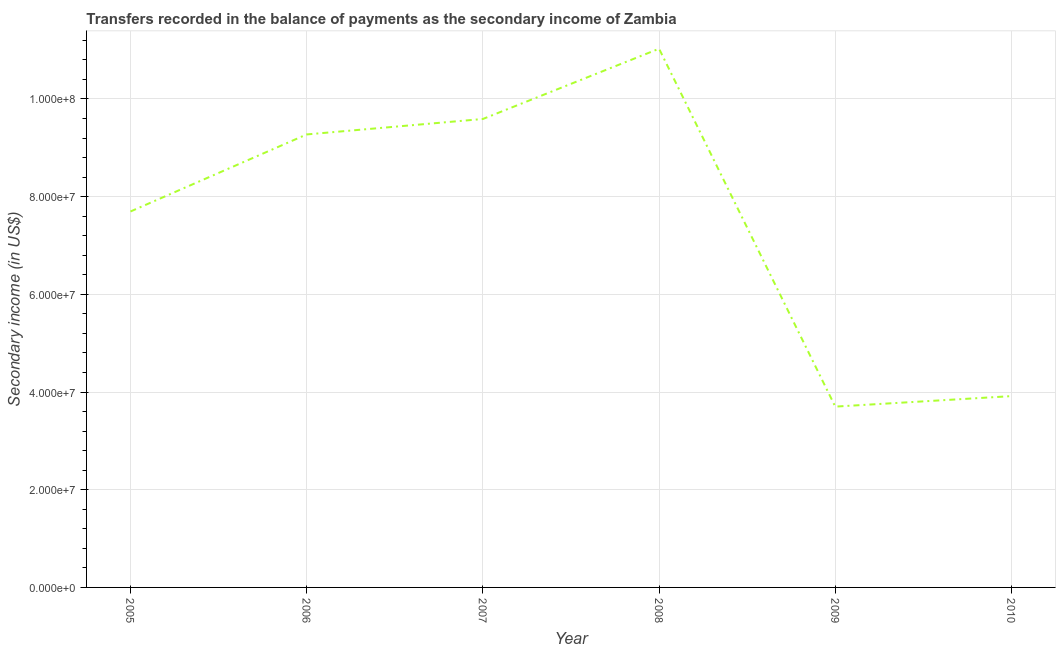What is the amount of secondary income in 2006?
Make the answer very short. 9.27e+07. Across all years, what is the maximum amount of secondary income?
Give a very brief answer. 1.10e+08. Across all years, what is the minimum amount of secondary income?
Provide a short and direct response. 3.70e+07. In which year was the amount of secondary income minimum?
Keep it short and to the point. 2009. What is the sum of the amount of secondary income?
Make the answer very short. 4.52e+08. What is the difference between the amount of secondary income in 2005 and 2009?
Give a very brief answer. 3.99e+07. What is the average amount of secondary income per year?
Your response must be concise. 7.53e+07. What is the median amount of secondary income?
Keep it short and to the point. 8.48e+07. In how many years, is the amount of secondary income greater than 80000000 US$?
Your answer should be compact. 3. Do a majority of the years between 2006 and 2008 (inclusive) have amount of secondary income greater than 88000000 US$?
Offer a terse response. Yes. What is the ratio of the amount of secondary income in 2007 to that in 2009?
Your response must be concise. 2.59. Is the amount of secondary income in 2005 less than that in 2008?
Offer a terse response. Yes. What is the difference between the highest and the second highest amount of secondary income?
Ensure brevity in your answer.  1.44e+07. What is the difference between the highest and the lowest amount of secondary income?
Ensure brevity in your answer.  7.33e+07. Does the amount of secondary income monotonically increase over the years?
Keep it short and to the point. No. How many years are there in the graph?
Make the answer very short. 6. Are the values on the major ticks of Y-axis written in scientific E-notation?
Give a very brief answer. Yes. What is the title of the graph?
Your response must be concise. Transfers recorded in the balance of payments as the secondary income of Zambia. What is the label or title of the Y-axis?
Ensure brevity in your answer.  Secondary income (in US$). What is the Secondary income (in US$) of 2005?
Provide a succinct answer. 7.70e+07. What is the Secondary income (in US$) in 2006?
Make the answer very short. 9.27e+07. What is the Secondary income (in US$) in 2007?
Your answer should be compact. 9.59e+07. What is the Secondary income (in US$) in 2008?
Make the answer very short. 1.10e+08. What is the Secondary income (in US$) in 2009?
Provide a short and direct response. 3.70e+07. What is the Secondary income (in US$) in 2010?
Provide a succinct answer. 3.92e+07. What is the difference between the Secondary income (in US$) in 2005 and 2006?
Ensure brevity in your answer.  -1.58e+07. What is the difference between the Secondary income (in US$) in 2005 and 2007?
Your response must be concise. -1.89e+07. What is the difference between the Secondary income (in US$) in 2005 and 2008?
Ensure brevity in your answer.  -3.33e+07. What is the difference between the Secondary income (in US$) in 2005 and 2009?
Give a very brief answer. 3.99e+07. What is the difference between the Secondary income (in US$) in 2005 and 2010?
Your answer should be very brief. 3.78e+07. What is the difference between the Secondary income (in US$) in 2006 and 2007?
Your response must be concise. -3.16e+06. What is the difference between the Secondary income (in US$) in 2006 and 2008?
Your response must be concise. -1.75e+07. What is the difference between the Secondary income (in US$) in 2006 and 2009?
Offer a terse response. 5.57e+07. What is the difference between the Secondary income (in US$) in 2006 and 2010?
Provide a succinct answer. 5.36e+07. What is the difference between the Secondary income (in US$) in 2007 and 2008?
Keep it short and to the point. -1.44e+07. What is the difference between the Secondary income (in US$) in 2007 and 2009?
Your answer should be very brief. 5.89e+07. What is the difference between the Secondary income (in US$) in 2007 and 2010?
Your answer should be compact. 5.67e+07. What is the difference between the Secondary income (in US$) in 2008 and 2009?
Give a very brief answer. 7.33e+07. What is the difference between the Secondary income (in US$) in 2008 and 2010?
Keep it short and to the point. 7.11e+07. What is the difference between the Secondary income (in US$) in 2009 and 2010?
Your answer should be compact. -2.15e+06. What is the ratio of the Secondary income (in US$) in 2005 to that in 2006?
Your answer should be very brief. 0.83. What is the ratio of the Secondary income (in US$) in 2005 to that in 2007?
Provide a succinct answer. 0.8. What is the ratio of the Secondary income (in US$) in 2005 to that in 2008?
Make the answer very short. 0.7. What is the ratio of the Secondary income (in US$) in 2005 to that in 2009?
Your response must be concise. 2.08. What is the ratio of the Secondary income (in US$) in 2005 to that in 2010?
Make the answer very short. 1.97. What is the ratio of the Secondary income (in US$) in 2006 to that in 2007?
Your response must be concise. 0.97. What is the ratio of the Secondary income (in US$) in 2006 to that in 2008?
Make the answer very short. 0.84. What is the ratio of the Secondary income (in US$) in 2006 to that in 2009?
Offer a terse response. 2.5. What is the ratio of the Secondary income (in US$) in 2006 to that in 2010?
Offer a very short reply. 2.37. What is the ratio of the Secondary income (in US$) in 2007 to that in 2008?
Your answer should be compact. 0.87. What is the ratio of the Secondary income (in US$) in 2007 to that in 2009?
Make the answer very short. 2.59. What is the ratio of the Secondary income (in US$) in 2007 to that in 2010?
Provide a succinct answer. 2.45. What is the ratio of the Secondary income (in US$) in 2008 to that in 2009?
Your answer should be compact. 2.98. What is the ratio of the Secondary income (in US$) in 2008 to that in 2010?
Make the answer very short. 2.82. What is the ratio of the Secondary income (in US$) in 2009 to that in 2010?
Ensure brevity in your answer.  0.94. 